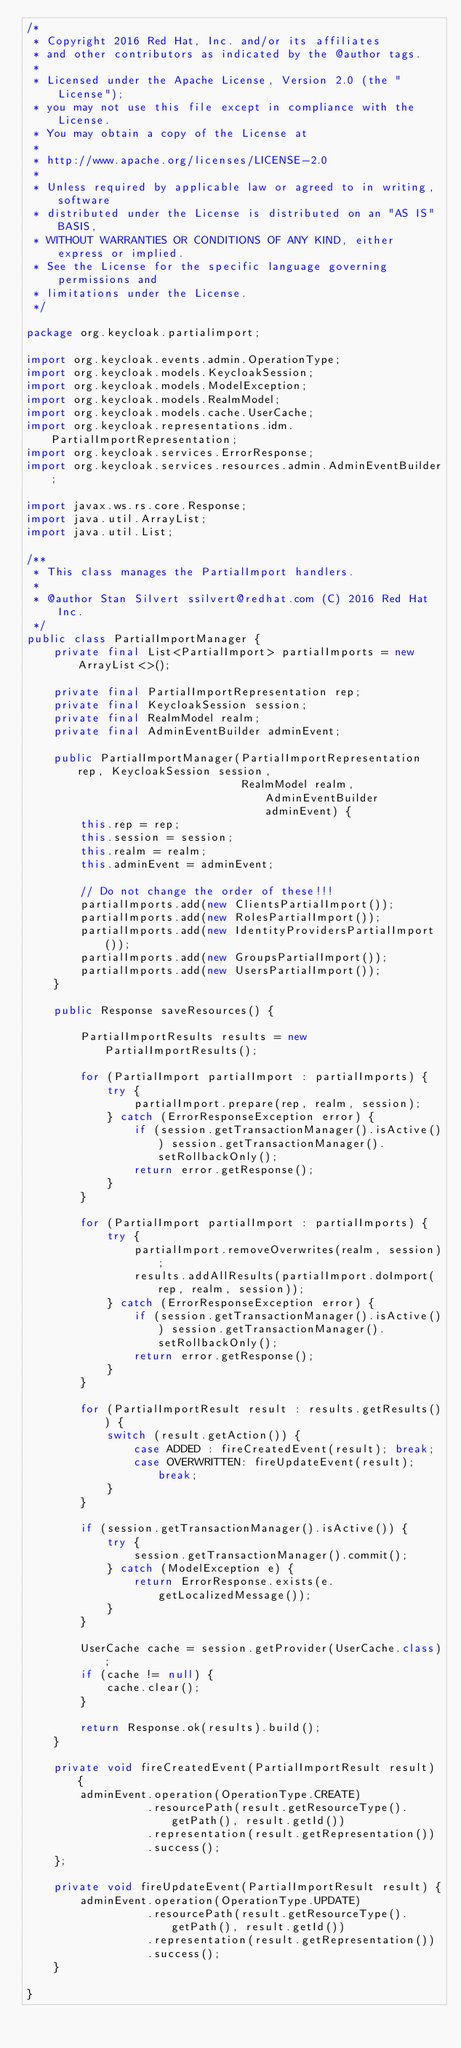Convert code to text. <code><loc_0><loc_0><loc_500><loc_500><_Java_>/*
 * Copyright 2016 Red Hat, Inc. and/or its affiliates
 * and other contributors as indicated by the @author tags.
 *
 * Licensed under the Apache License, Version 2.0 (the "License");
 * you may not use this file except in compliance with the License.
 * You may obtain a copy of the License at
 *
 * http://www.apache.org/licenses/LICENSE-2.0
 *
 * Unless required by applicable law or agreed to in writing, software
 * distributed under the License is distributed on an "AS IS" BASIS,
 * WITHOUT WARRANTIES OR CONDITIONS OF ANY KIND, either express or implied.
 * See the License for the specific language governing permissions and
 * limitations under the License.
 */

package org.keycloak.partialimport;

import org.keycloak.events.admin.OperationType;
import org.keycloak.models.KeycloakSession;
import org.keycloak.models.ModelException;
import org.keycloak.models.RealmModel;
import org.keycloak.models.cache.UserCache;
import org.keycloak.representations.idm.PartialImportRepresentation;
import org.keycloak.services.ErrorResponse;
import org.keycloak.services.resources.admin.AdminEventBuilder;

import javax.ws.rs.core.Response;
import java.util.ArrayList;
import java.util.List;

/**
 * This class manages the PartialImport handlers.
 *
 * @author Stan Silvert ssilvert@redhat.com (C) 2016 Red Hat Inc.
 */
public class PartialImportManager {
    private final List<PartialImport> partialImports = new ArrayList<>();

    private final PartialImportRepresentation rep;
    private final KeycloakSession session;
    private final RealmModel realm;
    private final AdminEventBuilder adminEvent;

    public PartialImportManager(PartialImportRepresentation rep, KeycloakSession session,
                                RealmModel realm, AdminEventBuilder adminEvent) {
        this.rep = rep;
        this.session = session;
        this.realm = realm;
        this.adminEvent = adminEvent;

        // Do not change the order of these!!!
        partialImports.add(new ClientsPartialImport());
        partialImports.add(new RolesPartialImport());
        partialImports.add(new IdentityProvidersPartialImport());
        partialImports.add(new GroupsPartialImport());
        partialImports.add(new UsersPartialImport());
    }

    public Response saveResources() {

        PartialImportResults results = new PartialImportResults();

        for (PartialImport partialImport : partialImports) {
            try {
                partialImport.prepare(rep, realm, session);
            } catch (ErrorResponseException error) {
                if (session.getTransactionManager().isActive()) session.getTransactionManager().setRollbackOnly();
                return error.getResponse();
            }
        }

        for (PartialImport partialImport : partialImports) {
            try {
                partialImport.removeOverwrites(realm, session);
                results.addAllResults(partialImport.doImport(rep, realm, session));
            } catch (ErrorResponseException error) {
                if (session.getTransactionManager().isActive()) session.getTransactionManager().setRollbackOnly();
                return error.getResponse();
            }
        }

        for (PartialImportResult result : results.getResults()) {
            switch (result.getAction()) {
                case ADDED : fireCreatedEvent(result); break;
                case OVERWRITTEN: fireUpdateEvent(result); break;
            }
        }

        if (session.getTransactionManager().isActive()) {
            try {
                session.getTransactionManager().commit();
            } catch (ModelException e) {
                return ErrorResponse.exists(e.getLocalizedMessage());
            }
        }

        UserCache cache = session.getProvider(UserCache.class);
        if (cache != null) {
            cache.clear();
        }

        return Response.ok(results).build();
    }

    private void fireCreatedEvent(PartialImportResult result) {
        adminEvent.operation(OperationType.CREATE)
                  .resourcePath(result.getResourceType().getPath(), result.getId())
                  .representation(result.getRepresentation())
                  .success();
    };

    private void fireUpdateEvent(PartialImportResult result) {
        adminEvent.operation(OperationType.UPDATE)
                  .resourcePath(result.getResourceType().getPath(), result.getId())
                  .representation(result.getRepresentation())
                  .success();
    }

}
</code> 